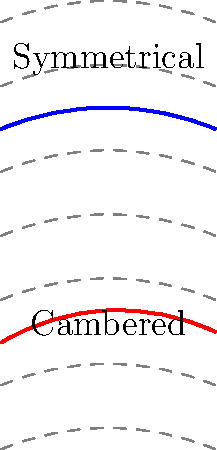Based on the fluid flow patterns shown in the diagram, which airfoil shape is likely to generate more lift? Explain your reasoning using concepts from fluid dynamics that a tech enthusiast might be familiar with from online research. To determine which airfoil shape generates more lift, we need to analyze the fluid flow patterns around each airfoil:

1. Observe the flow lines:
   - For the symmetrical airfoil (top), the flow lines are evenly spaced above and below.
   - For the cambered airfoil (bottom), the flow lines are more curved and spread out above the airfoil.

2. Apply Bernoulli's principle:
   $$p + \frac{1}{2}\rho v^2 = \text{constant}$$
   Where $p$ is pressure, $\rho$ is fluid density, and $v$ is fluid velocity.

3. Analyze the cambered airfoil:
   - The greater curvature on top creates a longer path for air to travel.
   - To cover this longer distance in the same time, the air must move faster over the top surface.

4. Apply the continuity equation:
   $$A_1v_1 = A_2v_2$$
   The narrower space above the cambered airfoil results in higher velocity.

5. Interpret Bernoulli's equation:
   - Higher velocity ($v$) on top means lower pressure ($p$).
   - Lower velocity below means higher pressure.

6. Calculate lift:
   $$\text{Lift} = (p_\text{bottom} - p_\text{top}) \times \text{wing area}$$
   The pressure difference creates an upward force (lift).

7. Compare to symmetrical airfoil:
   - The symmetrical airfoil has equal path lengths above and below.
   - This results in smaller pressure differences and less lift.

Therefore, the cambered airfoil generates more lift due to the greater pressure difference between its upper and lower surfaces.
Answer: Cambered airfoil generates more lift due to greater pressure difference. 